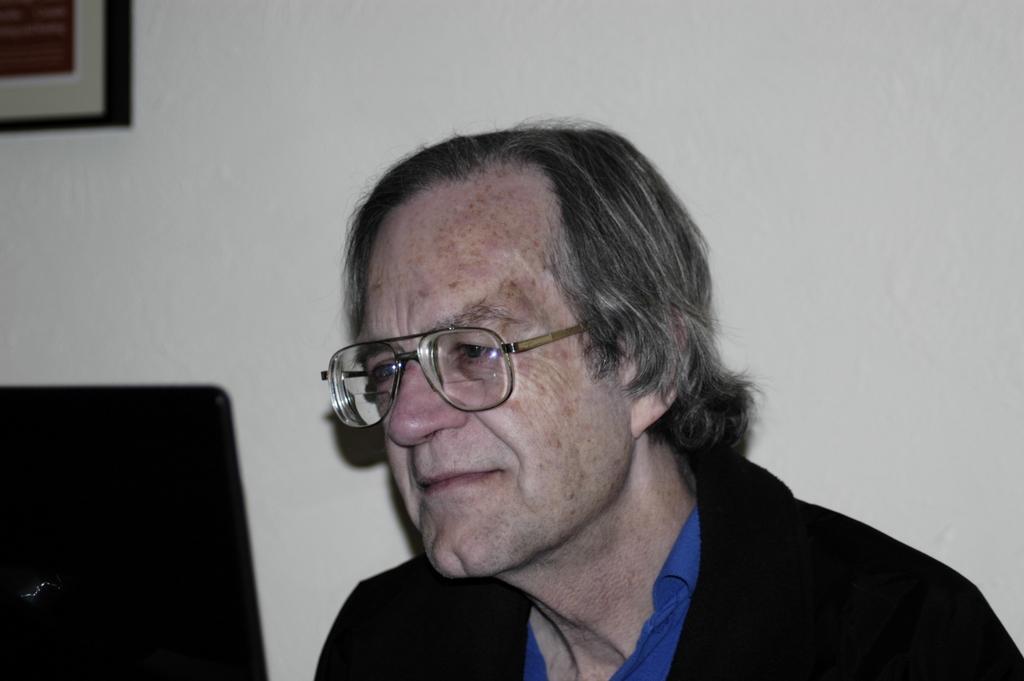Describe this image in one or two sentences. In this image, I can see an old man. He wore a suit, shirt and spectacle. This looks like an object, which is black in color. At the top left corner of the image, I can see a frame, which is attached to the wall. This wall looks white in color. 